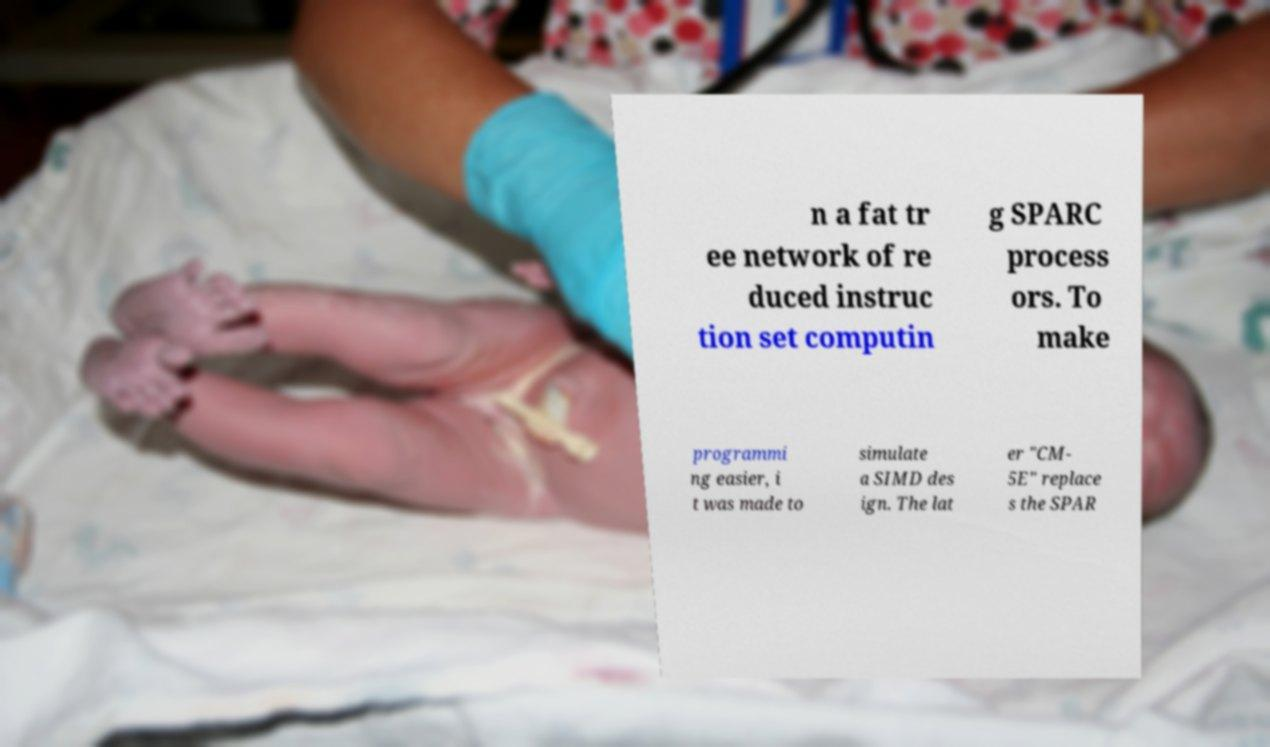Can you read and provide the text displayed in the image?This photo seems to have some interesting text. Can you extract and type it out for me? n a fat tr ee network of re duced instruc tion set computin g SPARC process ors. To make programmi ng easier, i t was made to simulate a SIMD des ign. The lat er "CM- 5E" replace s the SPAR 